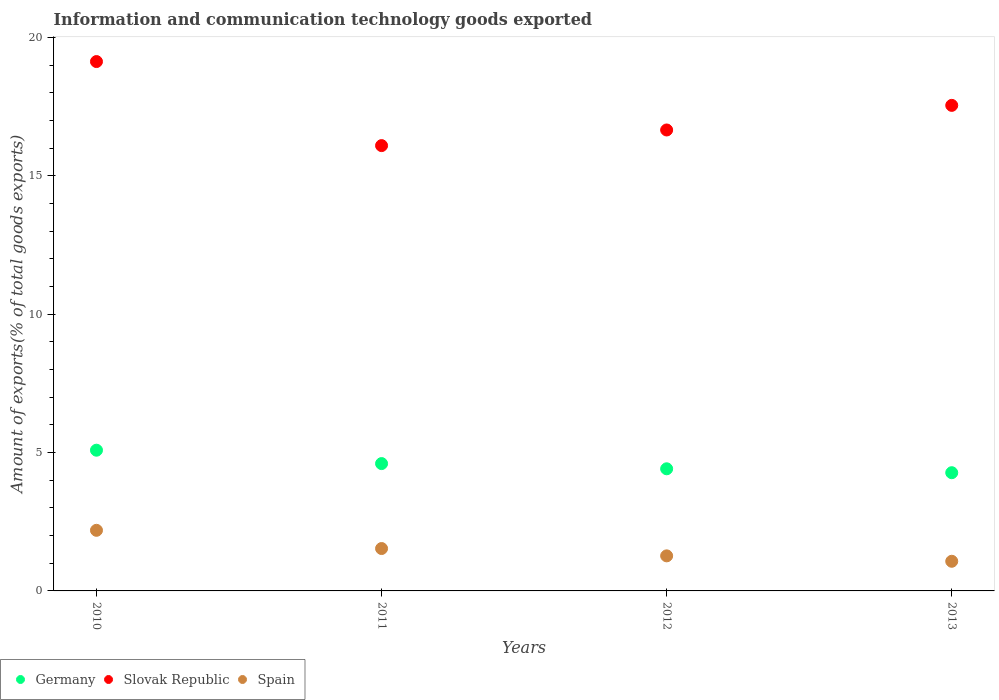How many different coloured dotlines are there?
Keep it short and to the point. 3. What is the amount of goods exported in Slovak Republic in 2013?
Provide a succinct answer. 17.55. Across all years, what is the maximum amount of goods exported in Slovak Republic?
Ensure brevity in your answer.  19.13. Across all years, what is the minimum amount of goods exported in Slovak Republic?
Keep it short and to the point. 16.1. In which year was the amount of goods exported in Spain maximum?
Provide a short and direct response. 2010. In which year was the amount of goods exported in Slovak Republic minimum?
Provide a succinct answer. 2011. What is the total amount of goods exported in Spain in the graph?
Make the answer very short. 6.06. What is the difference between the amount of goods exported in Germany in 2010 and that in 2011?
Ensure brevity in your answer.  0.48. What is the difference between the amount of goods exported in Germany in 2013 and the amount of goods exported in Slovak Republic in 2012?
Provide a succinct answer. -12.39. What is the average amount of goods exported in Spain per year?
Offer a terse response. 1.52. In the year 2013, what is the difference between the amount of goods exported in Slovak Republic and amount of goods exported in Spain?
Ensure brevity in your answer.  16.48. What is the ratio of the amount of goods exported in Spain in 2010 to that in 2013?
Your answer should be compact. 2.04. Is the amount of goods exported in Spain in 2010 less than that in 2013?
Provide a succinct answer. No. What is the difference between the highest and the second highest amount of goods exported in Germany?
Ensure brevity in your answer.  0.48. What is the difference between the highest and the lowest amount of goods exported in Spain?
Provide a succinct answer. 1.12. In how many years, is the amount of goods exported in Germany greater than the average amount of goods exported in Germany taken over all years?
Offer a very short reply. 2. Is the sum of the amount of goods exported in Slovak Republic in 2010 and 2013 greater than the maximum amount of goods exported in Spain across all years?
Your answer should be compact. Yes. Does the amount of goods exported in Germany monotonically increase over the years?
Your response must be concise. No. Are the values on the major ticks of Y-axis written in scientific E-notation?
Your answer should be very brief. No. Where does the legend appear in the graph?
Make the answer very short. Bottom left. How many legend labels are there?
Offer a terse response. 3. What is the title of the graph?
Keep it short and to the point. Information and communication technology goods exported. Does "Uzbekistan" appear as one of the legend labels in the graph?
Keep it short and to the point. No. What is the label or title of the Y-axis?
Offer a terse response. Amount of exports(% of total goods exports). What is the Amount of exports(% of total goods exports) in Germany in 2010?
Keep it short and to the point. 5.09. What is the Amount of exports(% of total goods exports) of Slovak Republic in 2010?
Ensure brevity in your answer.  19.13. What is the Amount of exports(% of total goods exports) in Spain in 2010?
Ensure brevity in your answer.  2.19. What is the Amount of exports(% of total goods exports) of Germany in 2011?
Your response must be concise. 4.6. What is the Amount of exports(% of total goods exports) in Slovak Republic in 2011?
Your answer should be compact. 16.1. What is the Amount of exports(% of total goods exports) of Spain in 2011?
Provide a short and direct response. 1.53. What is the Amount of exports(% of total goods exports) of Germany in 2012?
Make the answer very short. 4.41. What is the Amount of exports(% of total goods exports) in Slovak Republic in 2012?
Your response must be concise. 16.66. What is the Amount of exports(% of total goods exports) of Spain in 2012?
Your answer should be compact. 1.27. What is the Amount of exports(% of total goods exports) in Germany in 2013?
Keep it short and to the point. 4.27. What is the Amount of exports(% of total goods exports) in Slovak Republic in 2013?
Your answer should be very brief. 17.55. What is the Amount of exports(% of total goods exports) in Spain in 2013?
Your response must be concise. 1.07. Across all years, what is the maximum Amount of exports(% of total goods exports) of Germany?
Your answer should be compact. 5.09. Across all years, what is the maximum Amount of exports(% of total goods exports) in Slovak Republic?
Offer a very short reply. 19.13. Across all years, what is the maximum Amount of exports(% of total goods exports) of Spain?
Your answer should be compact. 2.19. Across all years, what is the minimum Amount of exports(% of total goods exports) of Germany?
Offer a very short reply. 4.27. Across all years, what is the minimum Amount of exports(% of total goods exports) of Slovak Republic?
Your answer should be very brief. 16.1. Across all years, what is the minimum Amount of exports(% of total goods exports) of Spain?
Your response must be concise. 1.07. What is the total Amount of exports(% of total goods exports) of Germany in the graph?
Your response must be concise. 18.38. What is the total Amount of exports(% of total goods exports) in Slovak Republic in the graph?
Provide a succinct answer. 69.44. What is the total Amount of exports(% of total goods exports) of Spain in the graph?
Ensure brevity in your answer.  6.06. What is the difference between the Amount of exports(% of total goods exports) in Germany in 2010 and that in 2011?
Give a very brief answer. 0.48. What is the difference between the Amount of exports(% of total goods exports) of Slovak Republic in 2010 and that in 2011?
Offer a very short reply. 3.04. What is the difference between the Amount of exports(% of total goods exports) of Spain in 2010 and that in 2011?
Offer a terse response. 0.66. What is the difference between the Amount of exports(% of total goods exports) of Germany in 2010 and that in 2012?
Ensure brevity in your answer.  0.67. What is the difference between the Amount of exports(% of total goods exports) in Slovak Republic in 2010 and that in 2012?
Your response must be concise. 2.47. What is the difference between the Amount of exports(% of total goods exports) in Spain in 2010 and that in 2012?
Offer a terse response. 0.92. What is the difference between the Amount of exports(% of total goods exports) of Germany in 2010 and that in 2013?
Give a very brief answer. 0.81. What is the difference between the Amount of exports(% of total goods exports) in Slovak Republic in 2010 and that in 2013?
Provide a succinct answer. 1.58. What is the difference between the Amount of exports(% of total goods exports) of Spain in 2010 and that in 2013?
Offer a very short reply. 1.12. What is the difference between the Amount of exports(% of total goods exports) in Germany in 2011 and that in 2012?
Ensure brevity in your answer.  0.19. What is the difference between the Amount of exports(% of total goods exports) of Slovak Republic in 2011 and that in 2012?
Make the answer very short. -0.56. What is the difference between the Amount of exports(% of total goods exports) in Spain in 2011 and that in 2012?
Provide a succinct answer. 0.26. What is the difference between the Amount of exports(% of total goods exports) of Germany in 2011 and that in 2013?
Make the answer very short. 0.33. What is the difference between the Amount of exports(% of total goods exports) of Slovak Republic in 2011 and that in 2013?
Your answer should be compact. -1.45. What is the difference between the Amount of exports(% of total goods exports) in Spain in 2011 and that in 2013?
Ensure brevity in your answer.  0.46. What is the difference between the Amount of exports(% of total goods exports) in Germany in 2012 and that in 2013?
Your response must be concise. 0.14. What is the difference between the Amount of exports(% of total goods exports) of Slovak Republic in 2012 and that in 2013?
Your answer should be compact. -0.89. What is the difference between the Amount of exports(% of total goods exports) of Spain in 2012 and that in 2013?
Your response must be concise. 0.2. What is the difference between the Amount of exports(% of total goods exports) of Germany in 2010 and the Amount of exports(% of total goods exports) of Slovak Republic in 2011?
Your answer should be compact. -11.01. What is the difference between the Amount of exports(% of total goods exports) in Germany in 2010 and the Amount of exports(% of total goods exports) in Spain in 2011?
Make the answer very short. 3.55. What is the difference between the Amount of exports(% of total goods exports) in Slovak Republic in 2010 and the Amount of exports(% of total goods exports) in Spain in 2011?
Give a very brief answer. 17.6. What is the difference between the Amount of exports(% of total goods exports) of Germany in 2010 and the Amount of exports(% of total goods exports) of Slovak Republic in 2012?
Your response must be concise. -11.57. What is the difference between the Amount of exports(% of total goods exports) of Germany in 2010 and the Amount of exports(% of total goods exports) of Spain in 2012?
Provide a succinct answer. 3.82. What is the difference between the Amount of exports(% of total goods exports) of Slovak Republic in 2010 and the Amount of exports(% of total goods exports) of Spain in 2012?
Your answer should be very brief. 17.87. What is the difference between the Amount of exports(% of total goods exports) of Germany in 2010 and the Amount of exports(% of total goods exports) of Slovak Republic in 2013?
Ensure brevity in your answer.  -12.46. What is the difference between the Amount of exports(% of total goods exports) of Germany in 2010 and the Amount of exports(% of total goods exports) of Spain in 2013?
Your response must be concise. 4.01. What is the difference between the Amount of exports(% of total goods exports) in Slovak Republic in 2010 and the Amount of exports(% of total goods exports) in Spain in 2013?
Your response must be concise. 18.06. What is the difference between the Amount of exports(% of total goods exports) in Germany in 2011 and the Amount of exports(% of total goods exports) in Slovak Republic in 2012?
Offer a terse response. -12.06. What is the difference between the Amount of exports(% of total goods exports) in Germany in 2011 and the Amount of exports(% of total goods exports) in Spain in 2012?
Make the answer very short. 3.34. What is the difference between the Amount of exports(% of total goods exports) in Slovak Republic in 2011 and the Amount of exports(% of total goods exports) in Spain in 2012?
Give a very brief answer. 14.83. What is the difference between the Amount of exports(% of total goods exports) of Germany in 2011 and the Amount of exports(% of total goods exports) of Slovak Republic in 2013?
Provide a succinct answer. -12.95. What is the difference between the Amount of exports(% of total goods exports) in Germany in 2011 and the Amount of exports(% of total goods exports) in Spain in 2013?
Give a very brief answer. 3.53. What is the difference between the Amount of exports(% of total goods exports) of Slovak Republic in 2011 and the Amount of exports(% of total goods exports) of Spain in 2013?
Provide a succinct answer. 15.02. What is the difference between the Amount of exports(% of total goods exports) in Germany in 2012 and the Amount of exports(% of total goods exports) in Slovak Republic in 2013?
Make the answer very short. -13.14. What is the difference between the Amount of exports(% of total goods exports) in Germany in 2012 and the Amount of exports(% of total goods exports) in Spain in 2013?
Give a very brief answer. 3.34. What is the difference between the Amount of exports(% of total goods exports) in Slovak Republic in 2012 and the Amount of exports(% of total goods exports) in Spain in 2013?
Your answer should be compact. 15.59. What is the average Amount of exports(% of total goods exports) in Germany per year?
Your response must be concise. 4.59. What is the average Amount of exports(% of total goods exports) in Slovak Republic per year?
Provide a short and direct response. 17.36. What is the average Amount of exports(% of total goods exports) in Spain per year?
Offer a terse response. 1.52. In the year 2010, what is the difference between the Amount of exports(% of total goods exports) in Germany and Amount of exports(% of total goods exports) in Slovak Republic?
Give a very brief answer. -14.05. In the year 2010, what is the difference between the Amount of exports(% of total goods exports) in Germany and Amount of exports(% of total goods exports) in Spain?
Keep it short and to the point. 2.9. In the year 2010, what is the difference between the Amount of exports(% of total goods exports) in Slovak Republic and Amount of exports(% of total goods exports) in Spain?
Your response must be concise. 16.94. In the year 2011, what is the difference between the Amount of exports(% of total goods exports) of Germany and Amount of exports(% of total goods exports) of Slovak Republic?
Provide a succinct answer. -11.49. In the year 2011, what is the difference between the Amount of exports(% of total goods exports) of Germany and Amount of exports(% of total goods exports) of Spain?
Offer a very short reply. 3.07. In the year 2011, what is the difference between the Amount of exports(% of total goods exports) of Slovak Republic and Amount of exports(% of total goods exports) of Spain?
Give a very brief answer. 14.56. In the year 2012, what is the difference between the Amount of exports(% of total goods exports) in Germany and Amount of exports(% of total goods exports) in Slovak Republic?
Make the answer very short. -12.25. In the year 2012, what is the difference between the Amount of exports(% of total goods exports) of Germany and Amount of exports(% of total goods exports) of Spain?
Keep it short and to the point. 3.15. In the year 2012, what is the difference between the Amount of exports(% of total goods exports) of Slovak Republic and Amount of exports(% of total goods exports) of Spain?
Offer a terse response. 15.39. In the year 2013, what is the difference between the Amount of exports(% of total goods exports) of Germany and Amount of exports(% of total goods exports) of Slovak Republic?
Give a very brief answer. -13.28. In the year 2013, what is the difference between the Amount of exports(% of total goods exports) in Germany and Amount of exports(% of total goods exports) in Spain?
Your response must be concise. 3.2. In the year 2013, what is the difference between the Amount of exports(% of total goods exports) in Slovak Republic and Amount of exports(% of total goods exports) in Spain?
Provide a succinct answer. 16.48. What is the ratio of the Amount of exports(% of total goods exports) of Germany in 2010 to that in 2011?
Ensure brevity in your answer.  1.11. What is the ratio of the Amount of exports(% of total goods exports) in Slovak Republic in 2010 to that in 2011?
Make the answer very short. 1.19. What is the ratio of the Amount of exports(% of total goods exports) in Spain in 2010 to that in 2011?
Provide a succinct answer. 1.43. What is the ratio of the Amount of exports(% of total goods exports) of Germany in 2010 to that in 2012?
Your answer should be compact. 1.15. What is the ratio of the Amount of exports(% of total goods exports) in Slovak Republic in 2010 to that in 2012?
Make the answer very short. 1.15. What is the ratio of the Amount of exports(% of total goods exports) of Spain in 2010 to that in 2012?
Offer a very short reply. 1.73. What is the ratio of the Amount of exports(% of total goods exports) in Germany in 2010 to that in 2013?
Provide a short and direct response. 1.19. What is the ratio of the Amount of exports(% of total goods exports) of Slovak Republic in 2010 to that in 2013?
Ensure brevity in your answer.  1.09. What is the ratio of the Amount of exports(% of total goods exports) in Spain in 2010 to that in 2013?
Your answer should be very brief. 2.04. What is the ratio of the Amount of exports(% of total goods exports) in Germany in 2011 to that in 2012?
Provide a succinct answer. 1.04. What is the ratio of the Amount of exports(% of total goods exports) of Slovak Republic in 2011 to that in 2012?
Provide a short and direct response. 0.97. What is the ratio of the Amount of exports(% of total goods exports) of Spain in 2011 to that in 2012?
Ensure brevity in your answer.  1.21. What is the ratio of the Amount of exports(% of total goods exports) in Germany in 2011 to that in 2013?
Your answer should be compact. 1.08. What is the ratio of the Amount of exports(% of total goods exports) in Slovak Republic in 2011 to that in 2013?
Give a very brief answer. 0.92. What is the ratio of the Amount of exports(% of total goods exports) of Spain in 2011 to that in 2013?
Offer a terse response. 1.43. What is the ratio of the Amount of exports(% of total goods exports) in Germany in 2012 to that in 2013?
Your response must be concise. 1.03. What is the ratio of the Amount of exports(% of total goods exports) in Slovak Republic in 2012 to that in 2013?
Keep it short and to the point. 0.95. What is the ratio of the Amount of exports(% of total goods exports) of Spain in 2012 to that in 2013?
Offer a terse response. 1.18. What is the difference between the highest and the second highest Amount of exports(% of total goods exports) of Germany?
Provide a short and direct response. 0.48. What is the difference between the highest and the second highest Amount of exports(% of total goods exports) in Slovak Republic?
Your response must be concise. 1.58. What is the difference between the highest and the second highest Amount of exports(% of total goods exports) of Spain?
Your answer should be compact. 0.66. What is the difference between the highest and the lowest Amount of exports(% of total goods exports) of Germany?
Offer a very short reply. 0.81. What is the difference between the highest and the lowest Amount of exports(% of total goods exports) in Slovak Republic?
Your answer should be very brief. 3.04. What is the difference between the highest and the lowest Amount of exports(% of total goods exports) of Spain?
Your answer should be very brief. 1.12. 